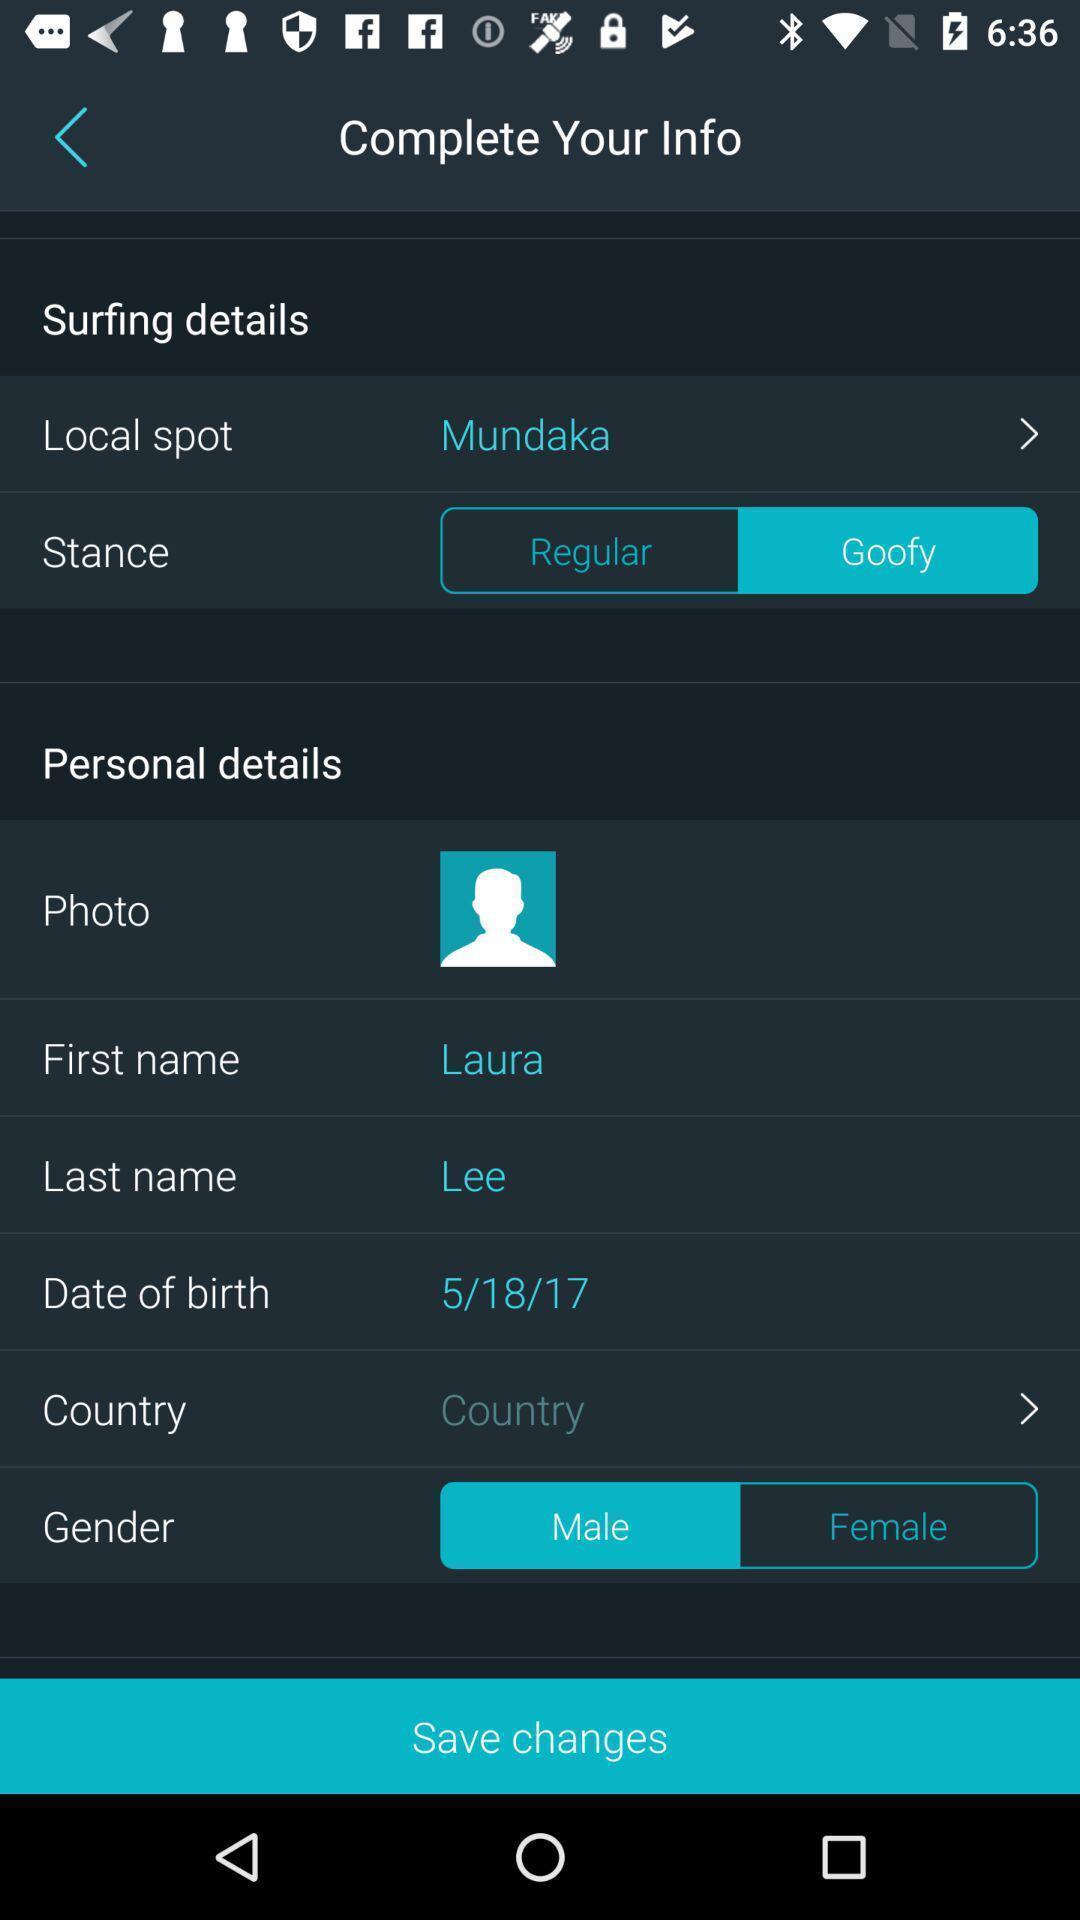Tell me about the visual elements in this screen capture. Page showing personal information in app. 